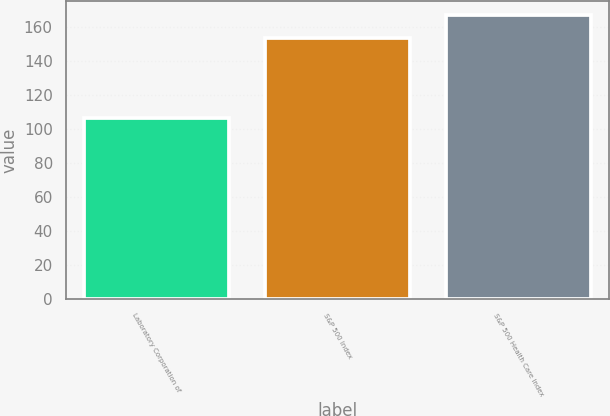<chart> <loc_0><loc_0><loc_500><loc_500><bar_chart><fcel>Laboratory Corporation of<fcel>S&P 500 Index<fcel>S&P 500 Health Care Index<nl><fcel>106.28<fcel>153.57<fcel>166.76<nl></chart> 